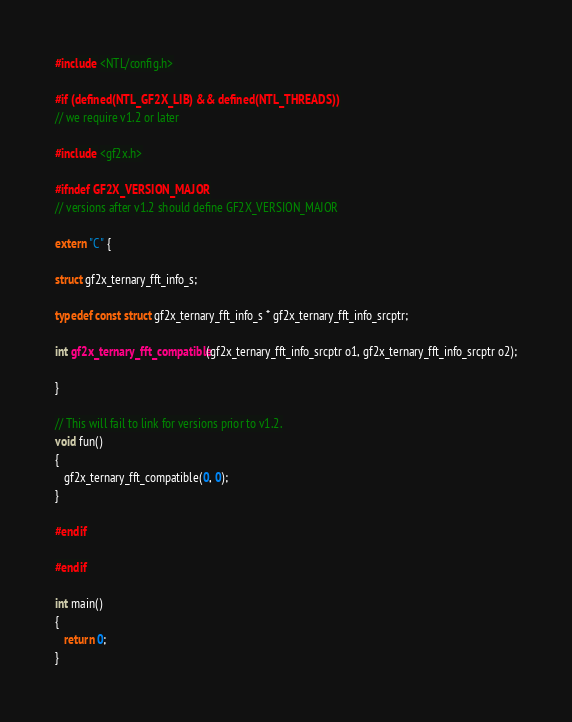<code> <loc_0><loc_0><loc_500><loc_500><_C++_>#include <NTL/config.h>

#if (defined(NTL_GF2X_LIB) && defined(NTL_THREADS))
// we require v1.2 or later

#include <gf2x.h>

#ifndef GF2X_VERSION_MAJOR
// versions after v1.2 should define GF2X_VERSION_MAJOR

extern "C" {

struct gf2x_ternary_fft_info_s;

typedef const struct gf2x_ternary_fft_info_s * gf2x_ternary_fft_info_srcptr;

int gf2x_ternary_fft_compatible(gf2x_ternary_fft_info_srcptr o1, gf2x_ternary_fft_info_srcptr o2);

}

// This will fail to link for versions prior to v1.2.
void fun()
{
   gf2x_ternary_fft_compatible(0, 0);
}

#endif

#endif

int main()
{
   return 0;
}
</code> 